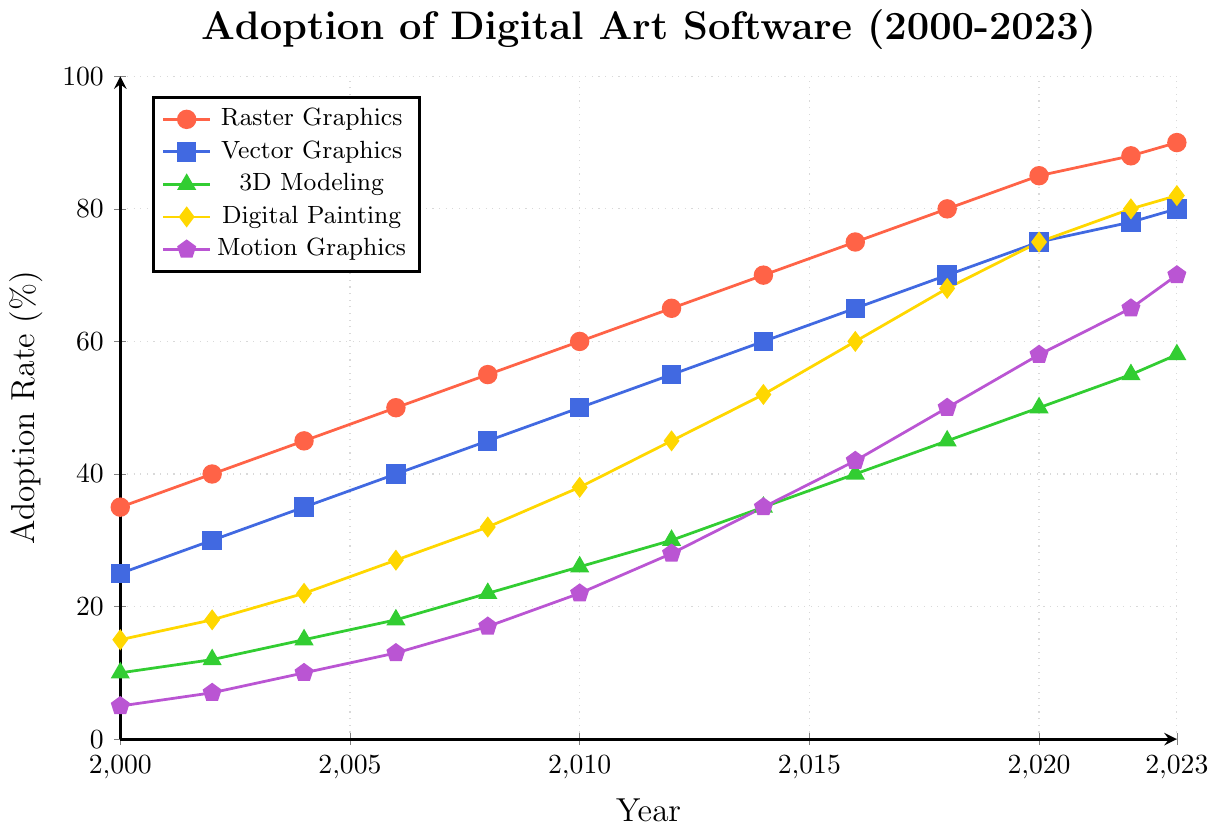What's the adoption rate of Raster Graphics software in the year 2023? To find the adoption rate of Raster Graphics software in 2023, you look directly at the plotted line in the figure corresponding to Raster Graphics and check the value at the year 2023.
Answer: 90% Which software had the lowest adoption rate in 2008? Examine the adoption rates of all software types for the year 2008, and identify the software with the smallest value.
Answer: Motion Graphics How did the adoption rate of Digital Painting software change from 2010 to 2020? Find the adoption rates of Digital Painting software in 2010 and 2020 from the figure and calculate the difference between the two values.
Answer: Increased by 37% Which two software types had the closest adoption rates in 2014? Compare the adoption rates of all software types in 2014 by looking at their respective points on the figure and identify the two that are nearest in value.
Answer: Raster Graphics and Vector Graphics What is the average adoption rate of Vector Graphics software from 2000 to 2023? Collect the adoption rates of Vector Graphics software for all years from the figure, sum them, and divide by the number of data points (2000 - 2023, inclusive, means 12 data points). Average = (25+30+35+40+45+50+55+60+65+70+75+78+80) / 13. The sum is 708, and dividing by 13 gives approximately 54.46.
Answer: 54.46% By how much did the adoption rate of Motion Graphics software increase from 2000 to 2016? Take the adoption rates of Motion Graphics software in 2000 and 2016 from the figure and compute the difference between the two values.
Answer: Increased by 37% In what year did Raster Graphics software surpass an 80% adoption rate? Identify the year at which the Raster Graphics adoption rate crosses the 80% threshold by examining the plotted line for Raster Graphics on the figure.
Answer: 2018 Which software type experienced the highest growth in adoption rate between any two consecutive data points? Determine the change in adoption rates between each pair of consecutive points for all software types, then find the highest of these changes. The figure shows that between 2010 and 2012, Digital Painting increases by 7%.
Answer: Digital Painting 